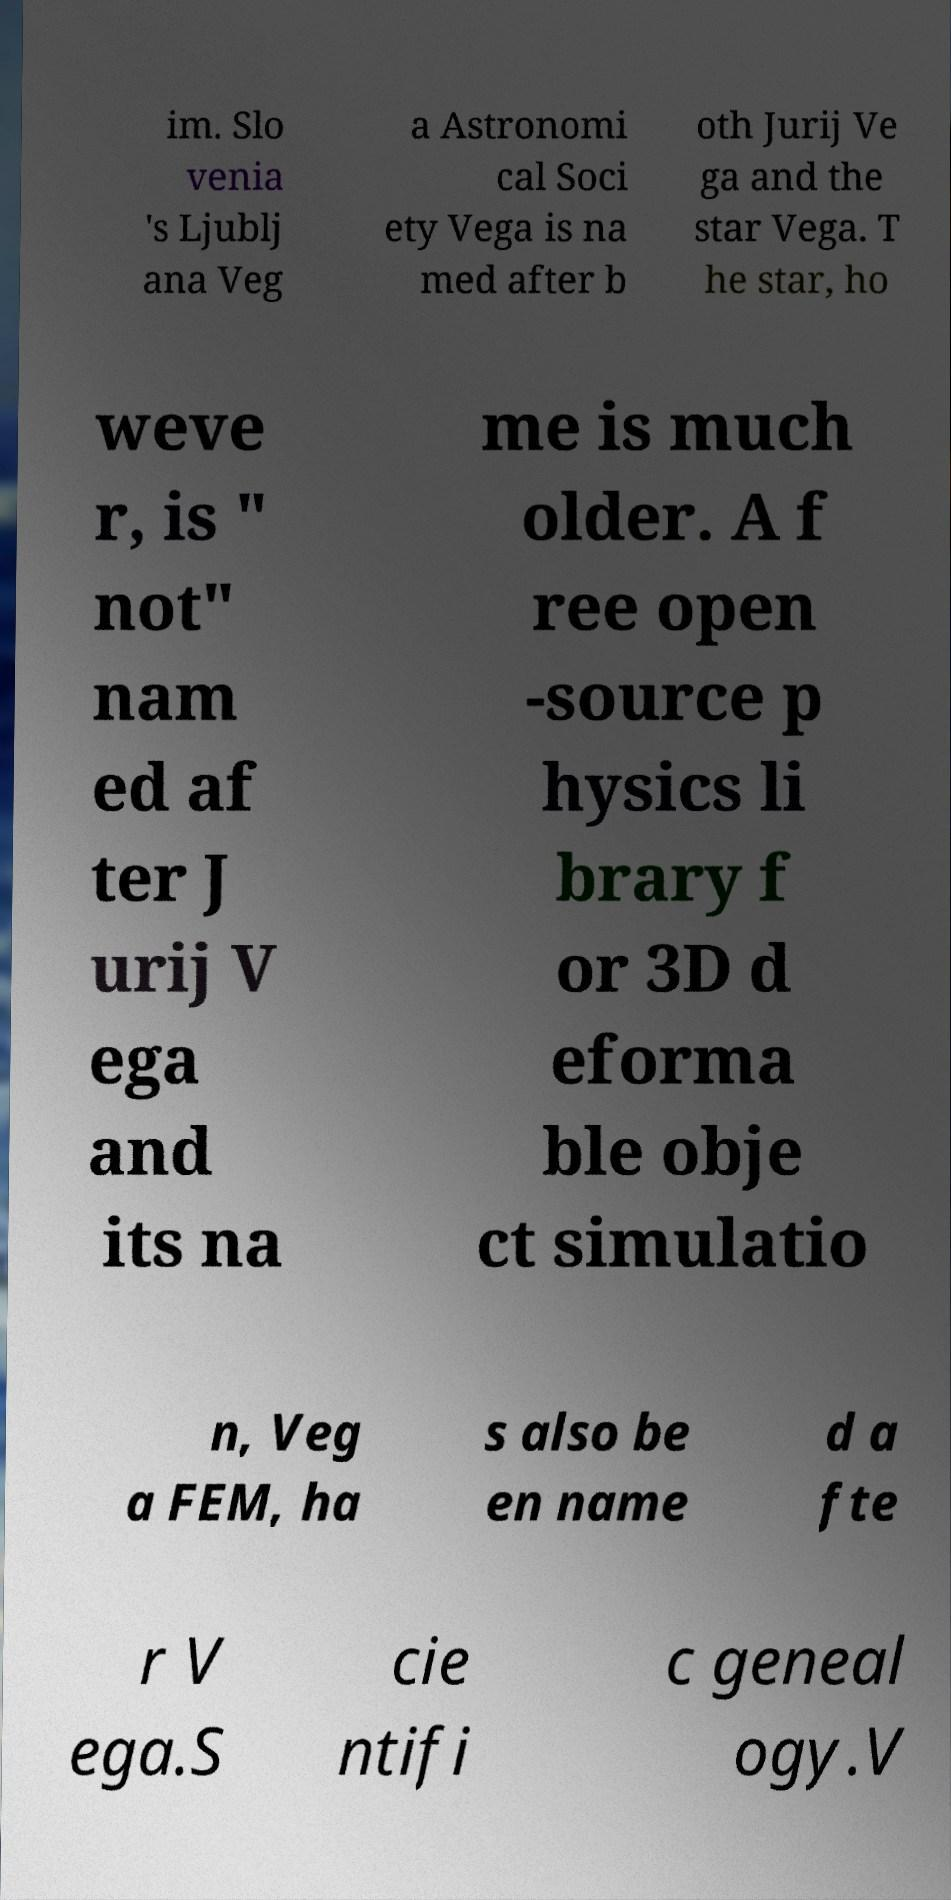Please read and relay the text visible in this image. What does it say? im. Slo venia 's Ljublj ana Veg a Astronomi cal Soci ety Vega is na med after b oth Jurij Ve ga and the star Vega. T he star, ho weve r, is " not" nam ed af ter J urij V ega and its na me is much older. A f ree open -source p hysics li brary f or 3D d eforma ble obje ct simulatio n, Veg a FEM, ha s also be en name d a fte r V ega.S cie ntifi c geneal ogy.V 